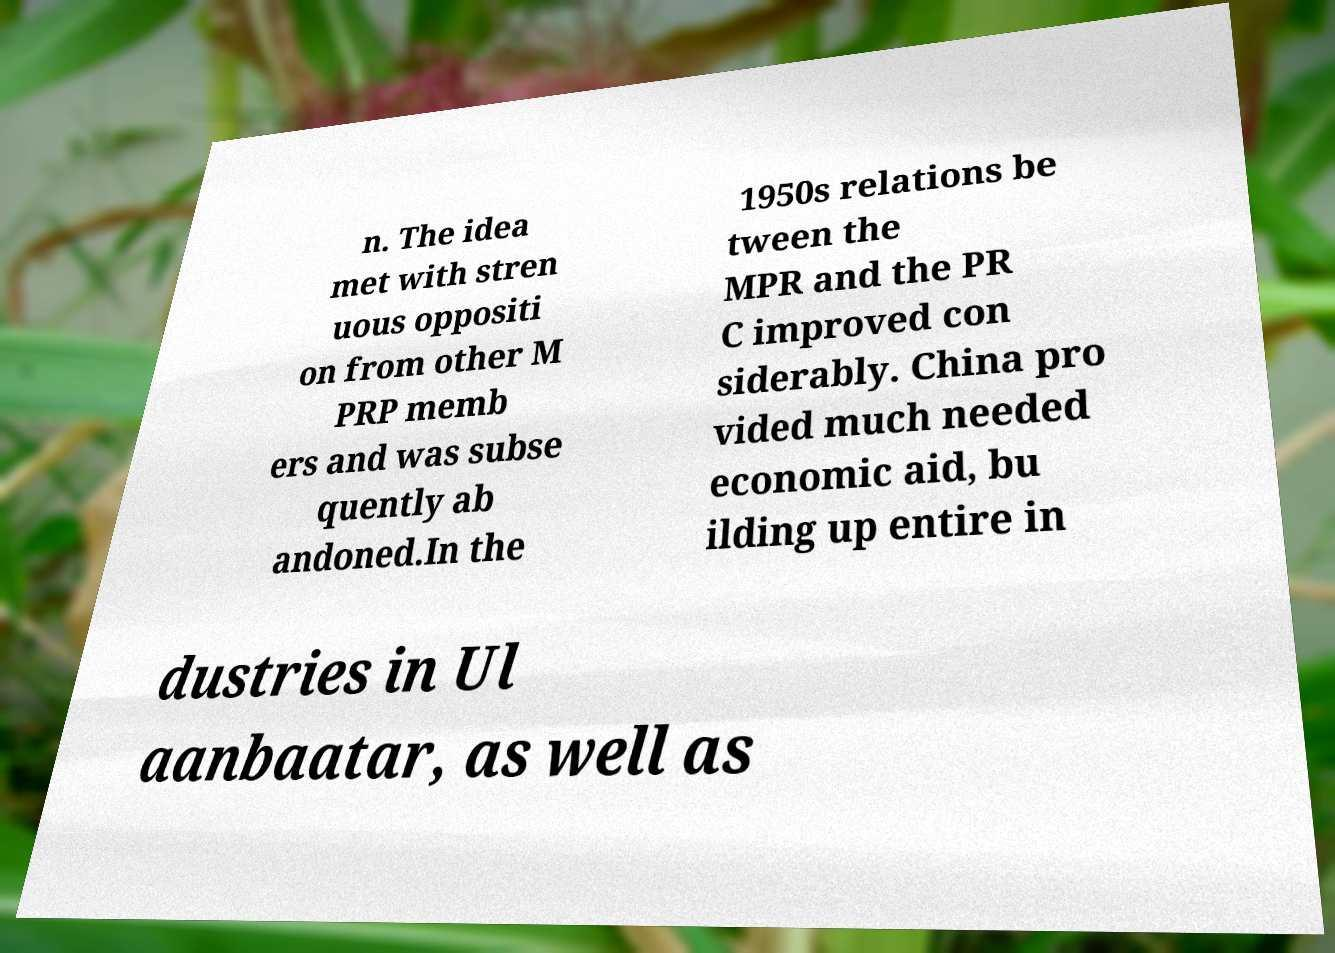Could you assist in decoding the text presented in this image and type it out clearly? n. The idea met with stren uous oppositi on from other M PRP memb ers and was subse quently ab andoned.In the 1950s relations be tween the MPR and the PR C improved con siderably. China pro vided much needed economic aid, bu ilding up entire in dustries in Ul aanbaatar, as well as 